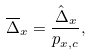<formula> <loc_0><loc_0><loc_500><loc_500>\overline { \Delta } _ { x } = \frac { \hat { \Delta } _ { x } } { p _ { x , c } } ,</formula> 